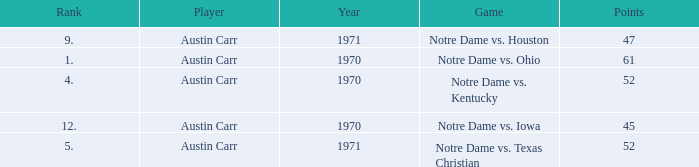Which Rank is the lowest one that has Points larger than 52, and a Year larger than 1970? None. 